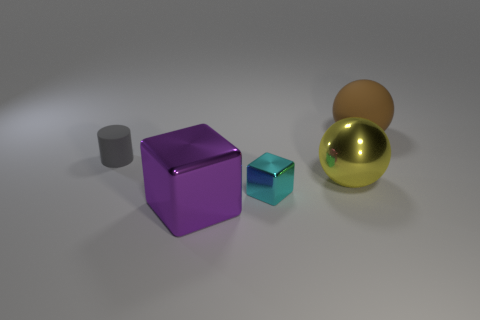Add 4 blue balls. How many objects exist? 9 Subtract all balls. How many objects are left? 3 Subtract 1 purple cubes. How many objects are left? 4 Subtract all spheres. Subtract all gray spheres. How many objects are left? 3 Add 4 gray cylinders. How many gray cylinders are left? 5 Add 4 tiny brown balls. How many tiny brown balls exist? 4 